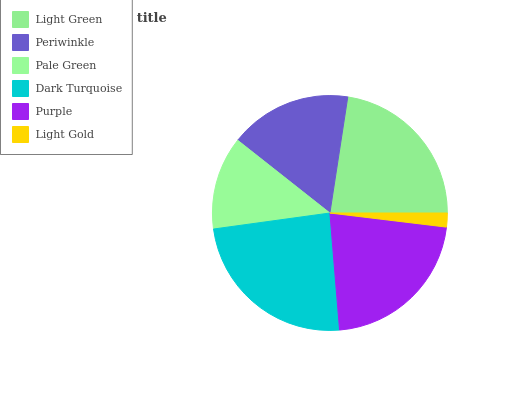Is Light Gold the minimum?
Answer yes or no. Yes. Is Dark Turquoise the maximum?
Answer yes or no. Yes. Is Periwinkle the minimum?
Answer yes or no. No. Is Periwinkle the maximum?
Answer yes or no. No. Is Light Green greater than Periwinkle?
Answer yes or no. Yes. Is Periwinkle less than Light Green?
Answer yes or no. Yes. Is Periwinkle greater than Light Green?
Answer yes or no. No. Is Light Green less than Periwinkle?
Answer yes or no. No. Is Purple the high median?
Answer yes or no. Yes. Is Periwinkle the low median?
Answer yes or no. Yes. Is Light Gold the high median?
Answer yes or no. No. Is Light Gold the low median?
Answer yes or no. No. 